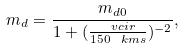Convert formula to latex. <formula><loc_0><loc_0><loc_500><loc_500>m _ { d } = \frac { m _ { d 0 } } { 1 + ( \frac { \ v c i r } { 1 5 0 \ k m s } ) ^ { - 2 } } ,</formula> 